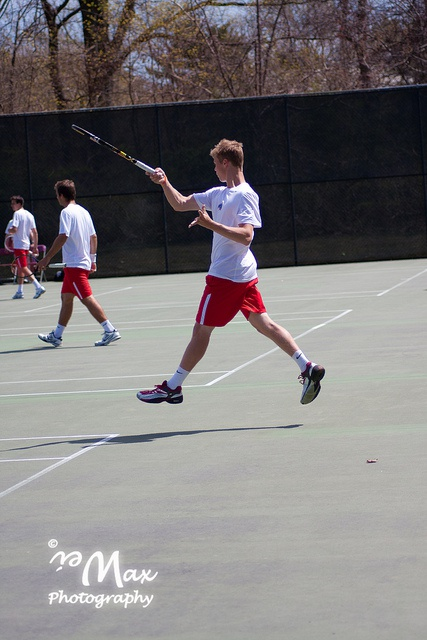Describe the objects in this image and their specific colors. I can see people in black, maroon, darkgray, and brown tones, people in black, maroon, lavender, and darkgray tones, people in black, lavender, maroon, darkgray, and gray tones, tennis racket in black, maroon, gray, and purple tones, and tennis racket in black, gray, and olive tones in this image. 